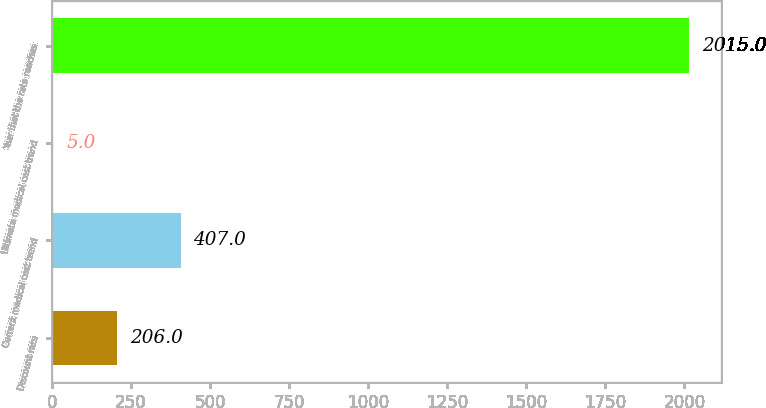Convert chart. <chart><loc_0><loc_0><loc_500><loc_500><bar_chart><fcel>Discount rate<fcel>Current medical cost trend<fcel>Ultimate medical cost trend<fcel>Year that the rate reaches<nl><fcel>206<fcel>407<fcel>5<fcel>2015<nl></chart> 